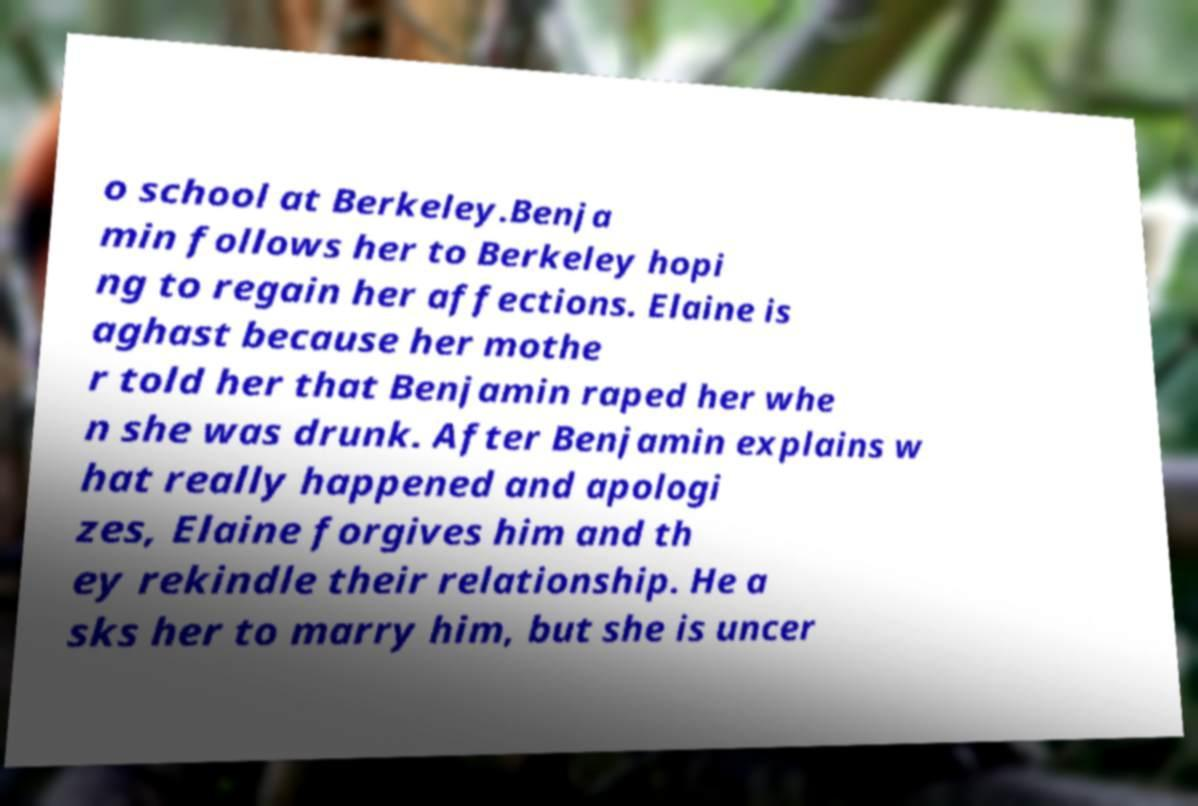I need the written content from this picture converted into text. Can you do that? o school at Berkeley.Benja min follows her to Berkeley hopi ng to regain her affections. Elaine is aghast because her mothe r told her that Benjamin raped her whe n she was drunk. After Benjamin explains w hat really happened and apologi zes, Elaine forgives him and th ey rekindle their relationship. He a sks her to marry him, but she is uncer 